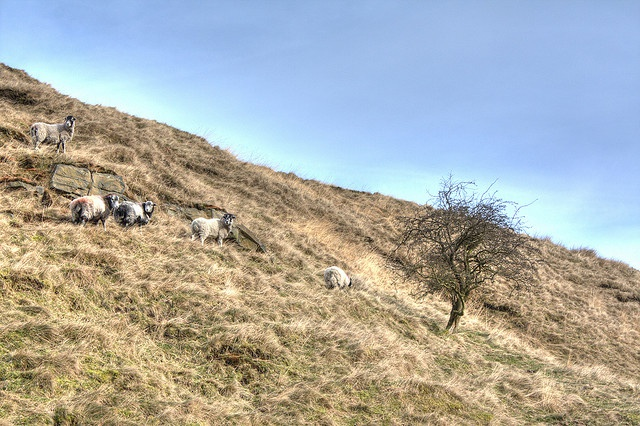Describe the objects in this image and their specific colors. I can see sheep in lightblue, ivory, gray, black, and darkgray tones, sheep in lightblue, darkgray, gray, tan, and lightgray tones, sheep in lightblue, beige, darkgray, gray, and tan tones, sheep in lightblue, black, gray, white, and darkgray tones, and sheep in lightblue, ivory, gray, darkgray, and tan tones in this image. 